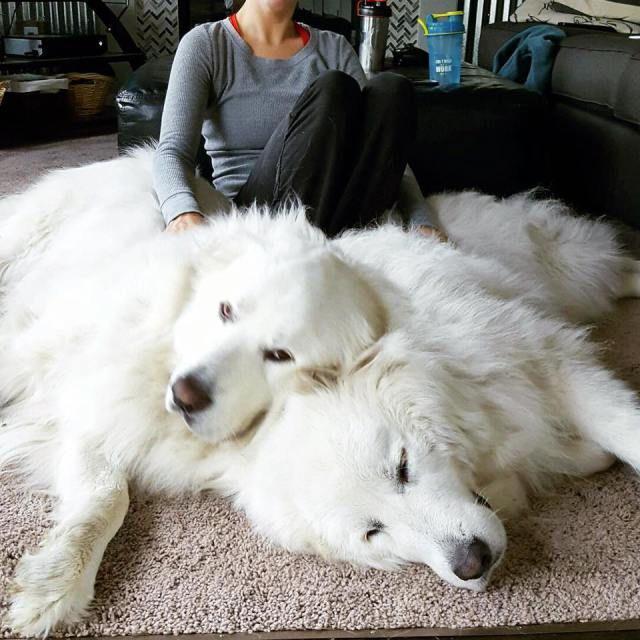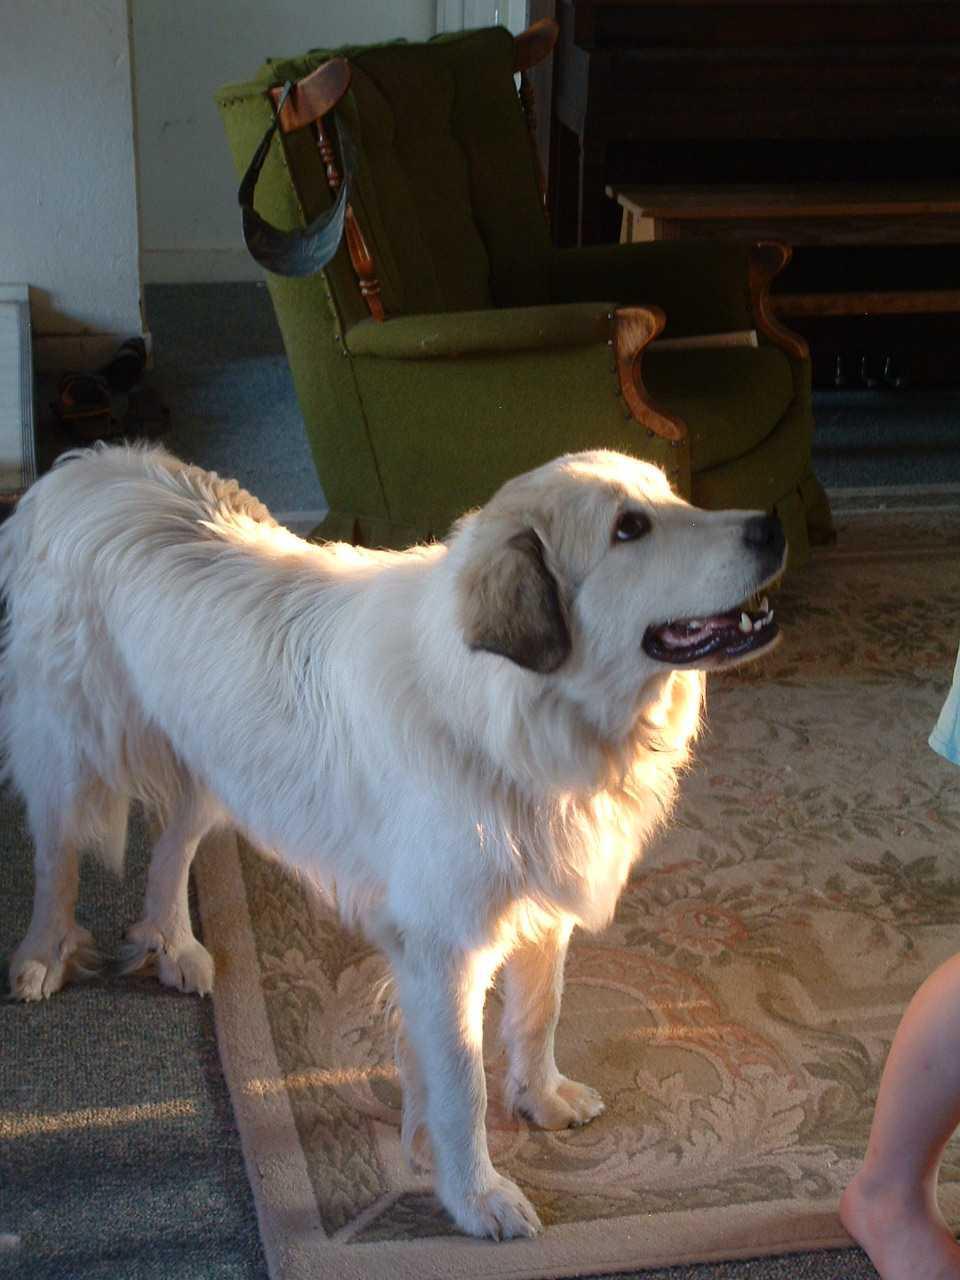The first image is the image on the left, the second image is the image on the right. Considering the images on both sides, is "Each image shows one person in an indoors setting with a large dog." valid? Answer yes or no. No. The first image is the image on the left, the second image is the image on the right. For the images displayed, is the sentence "An image shows exactly one person behind two white dogs." factually correct? Answer yes or no. Yes. 